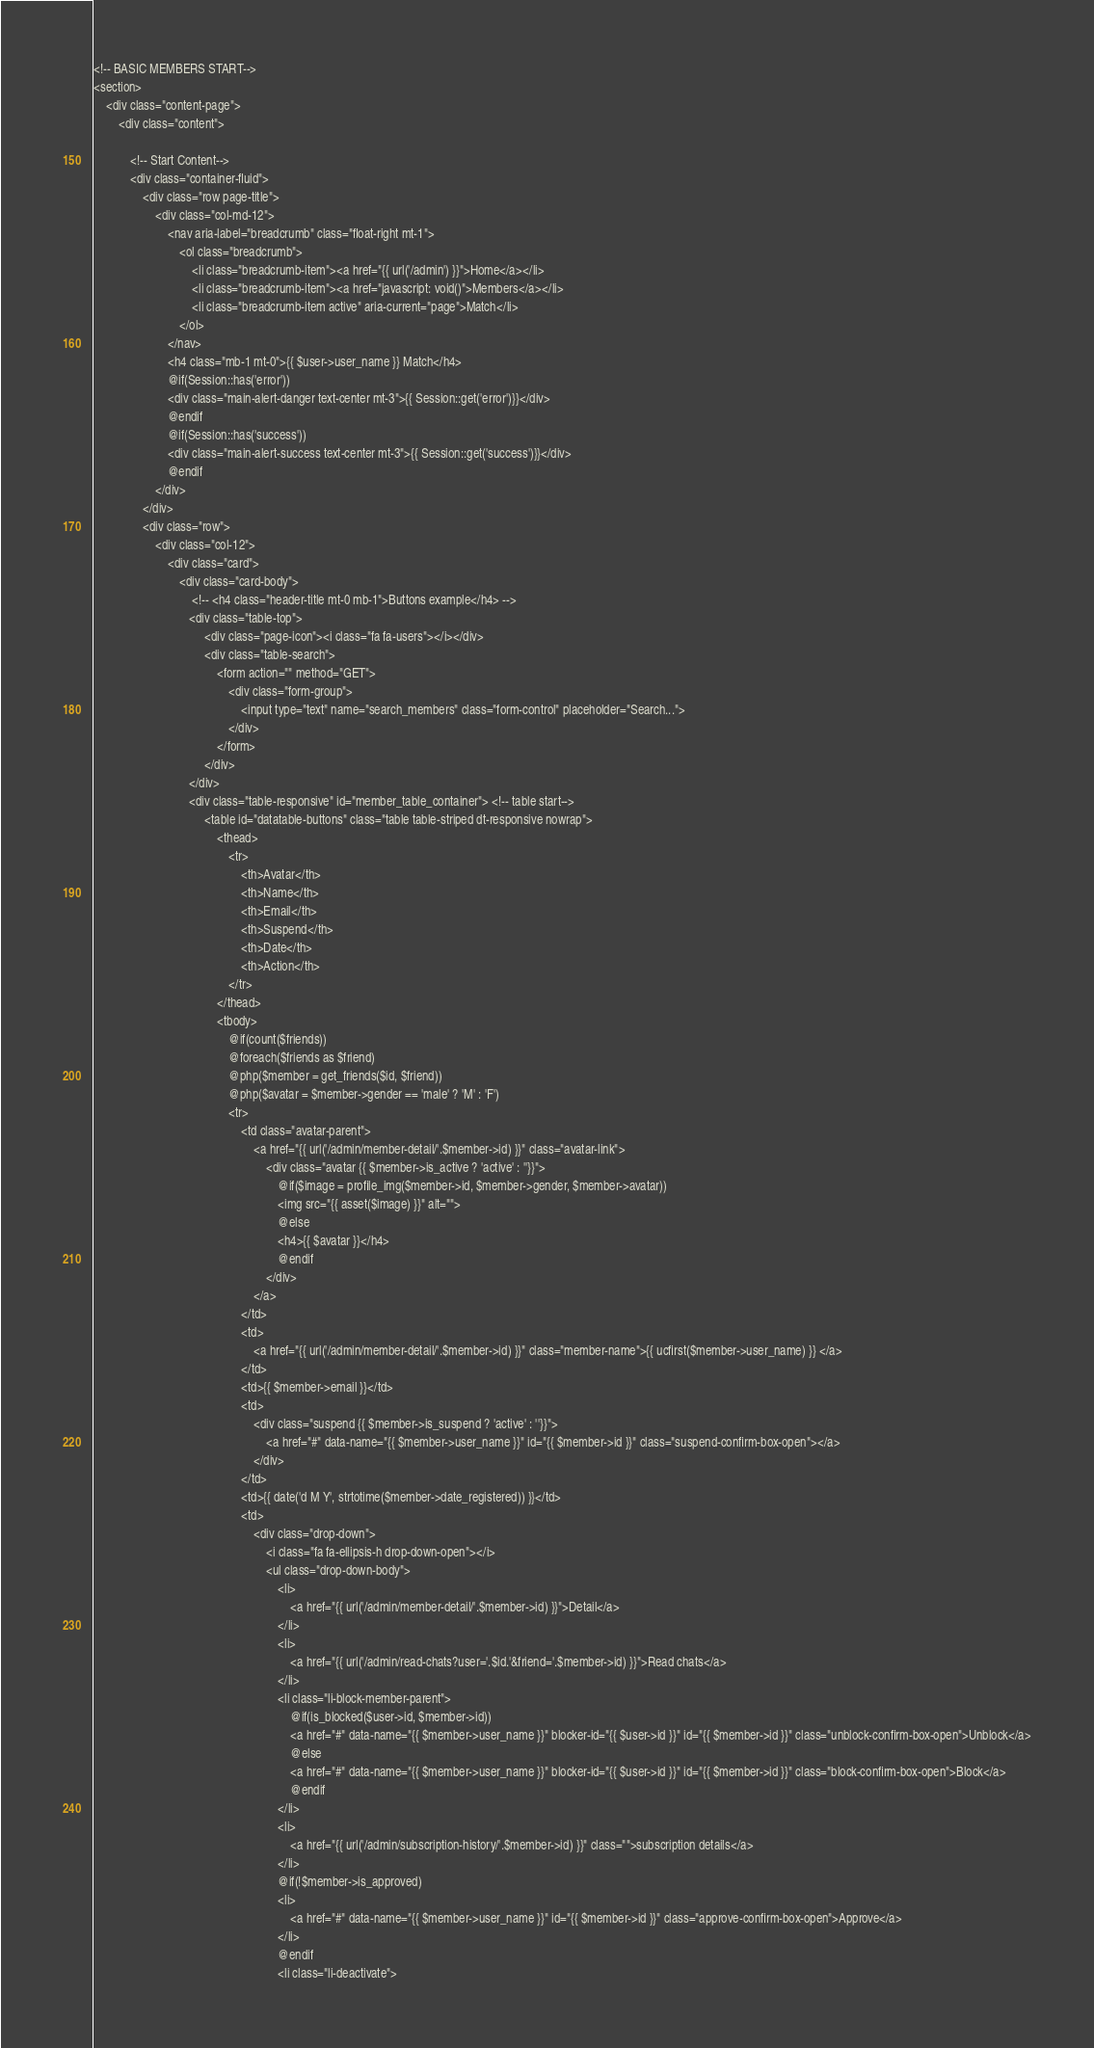<code> <loc_0><loc_0><loc_500><loc_500><_PHP_>




<!-- BASIC MEMBERS START-->
<section>
    <div class="content-page">
        <div class="content">
            
            <!-- Start Content-->
            <div class="container-fluid">
                <div class="row page-title">
                    <div class="col-md-12">
                        <nav aria-label="breadcrumb" class="float-right mt-1">
                            <ol class="breadcrumb">
                                <li class="breadcrumb-item"><a href="{{ url('/admin') }}">Home</a></li>
                                <li class="breadcrumb-item"><a href="javascript: void()">Members</a></li>
                                <li class="breadcrumb-item active" aria-current="page">Match</li>
                            </ol>
                        </nav>
                        <h4 class="mb-1 mt-0">{{ $user->user_name }} Match</h4>
                        @if(Session::has('error'))
                        <div class="main-alert-danger text-center mt-3">{{ Session::get('error')}}</div>
                        @endif
                        @if(Session::has('success'))
                        <div class="main-alert-success text-center mt-3">{{ Session::get('success')}}</div>
                        @endif
                    </div>
                </div>
                <div class="row">
                    <div class="col-12">
                        <div class="card">
                            <div class="card-body">
                                <!-- <h4 class="header-title mt-0 mb-1">Buttons example</h4> -->
                               <div class="table-top">
                                    <div class="page-icon"><i class="fa fa-users"></i></div>
                                    <div class="table-search">
                                        <form action="" method="GET">
                                            <div class="form-group">
                                                <input type="text" name="search_members" class="form-control" placeholder="Search...">
                                            </div>
                                        </form>
                                    </div>
                               </div>
                               <div class="table-responsive" id="member_table_container"> <!-- table start-->
                                    <table id="datatable-buttons" class="table table-striped dt-responsive nowrap">
                                        <thead>
                                            <tr>
                                                <th>Avatar</th>
                                                <th>Name</th>
                                                <th>Email</th>
                                                <th>Suspend</th>
                                                <th>Date</th>
                                                <th>Action</th>
                                            </tr>
                                        </thead>
                                        <tbody>
                                            @if(count($friends))
                                            @foreach($friends as $friend)
                                            @php($member = get_friends($id, $friend))
                                            @php($avatar = $member->gender == 'male' ? 'M' : 'F')
                                            <tr>
                                                <td class="avatar-parent">
                                                    <a href="{{ url('/admin/member-detail/'.$member->id) }}" class="avatar-link">
                                                        <div class="avatar {{ $member->is_active ? 'active' : ''}}">
                                                            @if($image = profile_img($member->id, $member->gender, $member->avatar))
                                                            <img src="{{ asset($image) }}" alt="">
                                                            @else
                                                            <h4>{{ $avatar }}</h4>
                                                            @endif
                                                        </div>
                                                    </a>
                                                </td>
                                                <td>
                                                    <a href="{{ url('/admin/member-detail/'.$member->id) }}" class="member-name">{{ ucfirst($member->user_name) }} </a>
                                                </td>
                                                <td>{{ $member->email }}</td>
                                                <td>
                                                    <div class="suspend {{ $member->is_suspend ? 'active' : ''}}">
                                                        <a href="#" data-name="{{ $member->user_name }}" id="{{ $member->id }}" class="suspend-confirm-box-open"></a>
                                                    </div>
                                                </td>
                                                <td>{{ date('d M Y', strtotime($member->date_registered)) }}</td>
                                                <td>
                                                    <div class="drop-down">
                                                        <i class="fa fa-ellipsis-h drop-down-open"></i>
                                                        <ul class="drop-down-body">
                                                            <li>
                                                                <a href="{{ url('/admin/member-detail/'.$member->id) }}">Detail</a>
                                                            </li>
                                                            <li>
                                                                <a href="{{ url('/admin/read-chats?user='.$id.'&friend='.$member->id) }}">Read chats</a>
                                                            </li>
                                                            <li class="li-block-member-parent">
                                                                @if(is_blocked($user->id, $member->id))
                                                                <a href="#" data-name="{{ $member->user_name }}" blocker-id="{{ $user->id }}" id="{{ $member->id }}" class="unblock-confirm-box-open">Unblock</a>
                                                                @else
                                                                <a href="#" data-name="{{ $member->user_name }}" blocker-id="{{ $user->id }}" id="{{ $member->id }}" class="block-confirm-box-open">Block</a>
                                                                @endif
                                                            </li>
                                                            <li>
                                                                <a href="{{ url('/admin/subscription-history/'.$member->id) }}" class="">subscription details</a>
                                                            </li>
                                                            @if(!$member->is_approved)
                                                            <li>
                                                                <a href="#" data-name="{{ $member->user_name }}" id="{{ $member->id }}" class="approve-confirm-box-open">Approve</a>
                                                            </li>
                                                            @endif
                                                            <li class="li-deactivate"></code> 